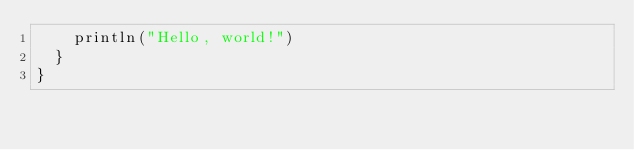<code> <loc_0><loc_0><loc_500><loc_500><_Scala_>		println("Hello, world!")
	}
}</code> 